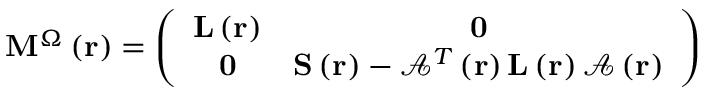<formula> <loc_0><loc_0><loc_500><loc_500>M ^ { \Omega } \left ( r \right ) = \left ( \begin{array} { c c } { L \left ( r \right ) } & { 0 } \\ { 0 } & { S \left ( r \right ) - \mathcal { A } ^ { T } \left ( r \right ) L \left ( r \right ) \mathcal { A } \left ( r \right ) } \end{array} \right )</formula> 